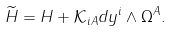Convert formula to latex. <formula><loc_0><loc_0><loc_500><loc_500>\widetilde { H } = H + \mathcal { K } _ { i A } d y ^ { i } \wedge \Omega ^ { A } .</formula> 